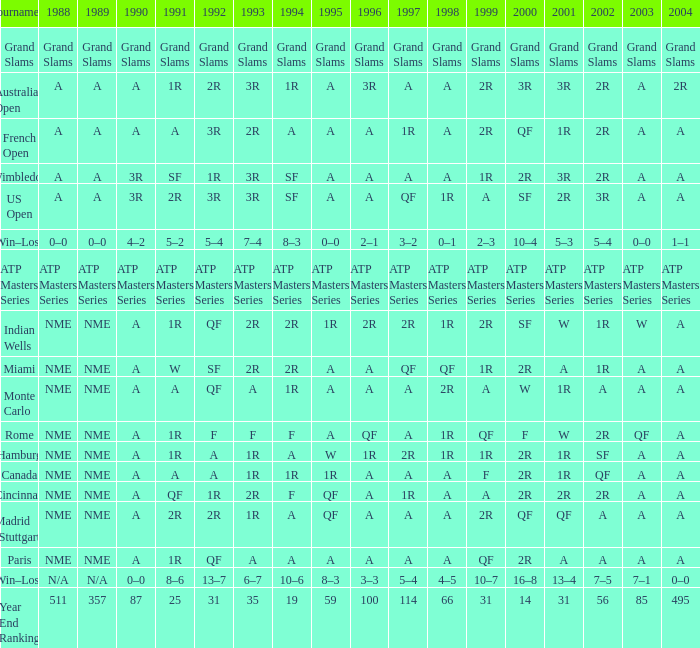Give me the full table as a dictionary. {'header': ['Tournament', '1988', '1989', '1990', '1991', '1992', '1993', '1994', '1995', '1996', '1997', '1998', '1999', '2000', '2001', '2002', '2003', '2004'], 'rows': [['Grand Slams', 'Grand Slams', 'Grand Slams', 'Grand Slams', 'Grand Slams', 'Grand Slams', 'Grand Slams', 'Grand Slams', 'Grand Slams', 'Grand Slams', 'Grand Slams', 'Grand Slams', 'Grand Slams', 'Grand Slams', 'Grand Slams', 'Grand Slams', 'Grand Slams', 'Grand Slams'], ['Australian Open', 'A', 'A', 'A', '1R', '2R', '3R', '1R', 'A', '3R', 'A', 'A', '2R', '3R', '3R', '2R', 'A', '2R'], ['French Open', 'A', 'A', 'A', 'A', '3R', '2R', 'A', 'A', 'A', '1R', 'A', '2R', 'QF', '1R', '2R', 'A', 'A'], ['Wimbledon', 'A', 'A', '3R', 'SF', '1R', '3R', 'SF', 'A', 'A', 'A', 'A', '1R', '2R', '3R', '2R', 'A', 'A'], ['US Open', 'A', 'A', '3R', '2R', '3R', '3R', 'SF', 'A', 'A', 'QF', '1R', 'A', 'SF', '2R', '3R', 'A', 'A'], ['Win–Loss', '0–0', '0–0', '4–2', '5–2', '5–4', '7–4', '8–3', '0–0', '2–1', '3–2', '0–1', '2–3', '10–4', '5–3', '5–4', '0–0', '1–1'], ['ATP Masters Series', 'ATP Masters Series', 'ATP Masters Series', 'ATP Masters Series', 'ATP Masters Series', 'ATP Masters Series', 'ATP Masters Series', 'ATP Masters Series', 'ATP Masters Series', 'ATP Masters Series', 'ATP Masters Series', 'ATP Masters Series', 'ATP Masters Series', 'ATP Masters Series', 'ATP Masters Series', 'ATP Masters Series', 'ATP Masters Series', 'ATP Masters Series'], ['Indian Wells', 'NME', 'NME', 'A', '1R', 'QF', '2R', '2R', '1R', '2R', '2R', '1R', '2R', 'SF', 'W', '1R', 'W', 'A'], ['Miami', 'NME', 'NME', 'A', 'W', 'SF', '2R', '2R', 'A', 'A', 'QF', 'QF', '1R', '2R', 'A', '1R', 'A', 'A'], ['Monte Carlo', 'NME', 'NME', 'A', 'A', 'QF', 'A', '1R', 'A', 'A', 'A', '2R', 'A', 'W', '1R', 'A', 'A', 'A'], ['Rome', 'NME', 'NME', 'A', '1R', 'F', 'F', 'F', 'A', 'QF', 'A', '1R', 'QF', 'F', 'W', '2R', 'QF', 'A'], ['Hamburg', 'NME', 'NME', 'A', '1R', 'A', '1R', 'A', 'W', '1R', '2R', '1R', '1R', '2R', '1R', 'SF', 'A', 'A'], ['Canada', 'NME', 'NME', 'A', 'A', 'A', '1R', '1R', '1R', 'A', 'A', 'A', 'F', '2R', '1R', 'QF', 'A', 'A'], ['Cincinnati', 'NME', 'NME', 'A', 'QF', '1R', '2R', 'F', 'QF', 'A', '1R', 'A', 'A', '2R', '2R', '2R', 'A', 'A'], ['Madrid (Stuttgart)', 'NME', 'NME', 'A', '2R', '2R', '1R', 'A', 'QF', 'A', 'A', 'A', '2R', 'QF', 'QF', 'A', 'A', 'A'], ['Paris', 'NME', 'NME', 'A', '1R', 'QF', 'A', 'A', 'A', 'A', 'A', 'A', 'QF', '2R', 'A', 'A', 'A', 'A'], ['Win–Loss', 'N/A', 'N/A', '0–0', '8–6', '13–7', '6–7', '10–6', '8–3', '3–3', '5–4', '4–5', '10–7', '16–8', '13–4', '7–5', '7–1', '0–0'], ['Year End Ranking', '511', '357', '87', '25', '31', '35', '19', '59', '100', '114', '66', '31', '14', '31', '56', '85', '495']]} What shows for 2002 when the 1991 is w? 1R. 